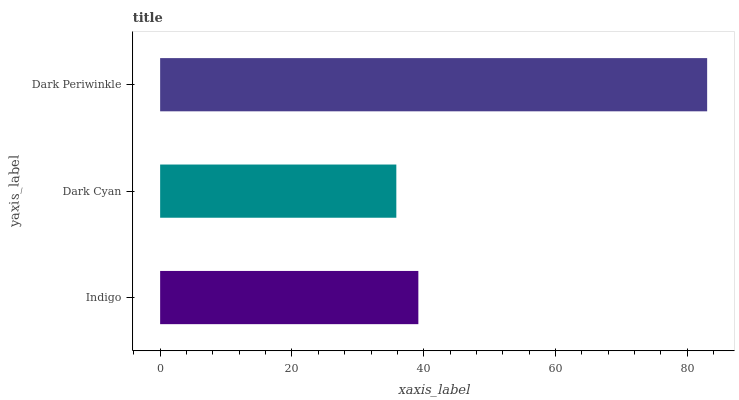Is Dark Cyan the minimum?
Answer yes or no. Yes. Is Dark Periwinkle the maximum?
Answer yes or no. Yes. Is Dark Periwinkle the minimum?
Answer yes or no. No. Is Dark Cyan the maximum?
Answer yes or no. No. Is Dark Periwinkle greater than Dark Cyan?
Answer yes or no. Yes. Is Dark Cyan less than Dark Periwinkle?
Answer yes or no. Yes. Is Dark Cyan greater than Dark Periwinkle?
Answer yes or no. No. Is Dark Periwinkle less than Dark Cyan?
Answer yes or no. No. Is Indigo the high median?
Answer yes or no. Yes. Is Indigo the low median?
Answer yes or no. Yes. Is Dark Cyan the high median?
Answer yes or no. No. Is Dark Cyan the low median?
Answer yes or no. No. 